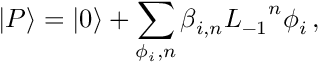Convert formula to latex. <formula><loc_0><loc_0><loc_500><loc_500>| P \rangle = | 0 \rangle + \sum _ { \phi _ { i } , n } \beta _ { i , n } { L _ { - 1 } } ^ { n } \phi _ { i } \, ,</formula> 